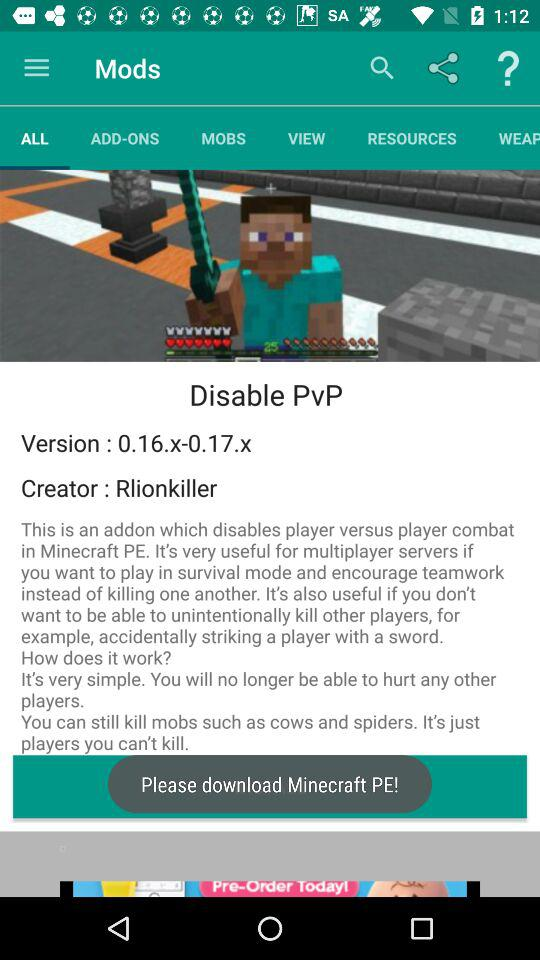How many versions of Minecraft PE are supported by this mod?
Answer the question using a single word or phrase. 0.16.x-0.17.x 